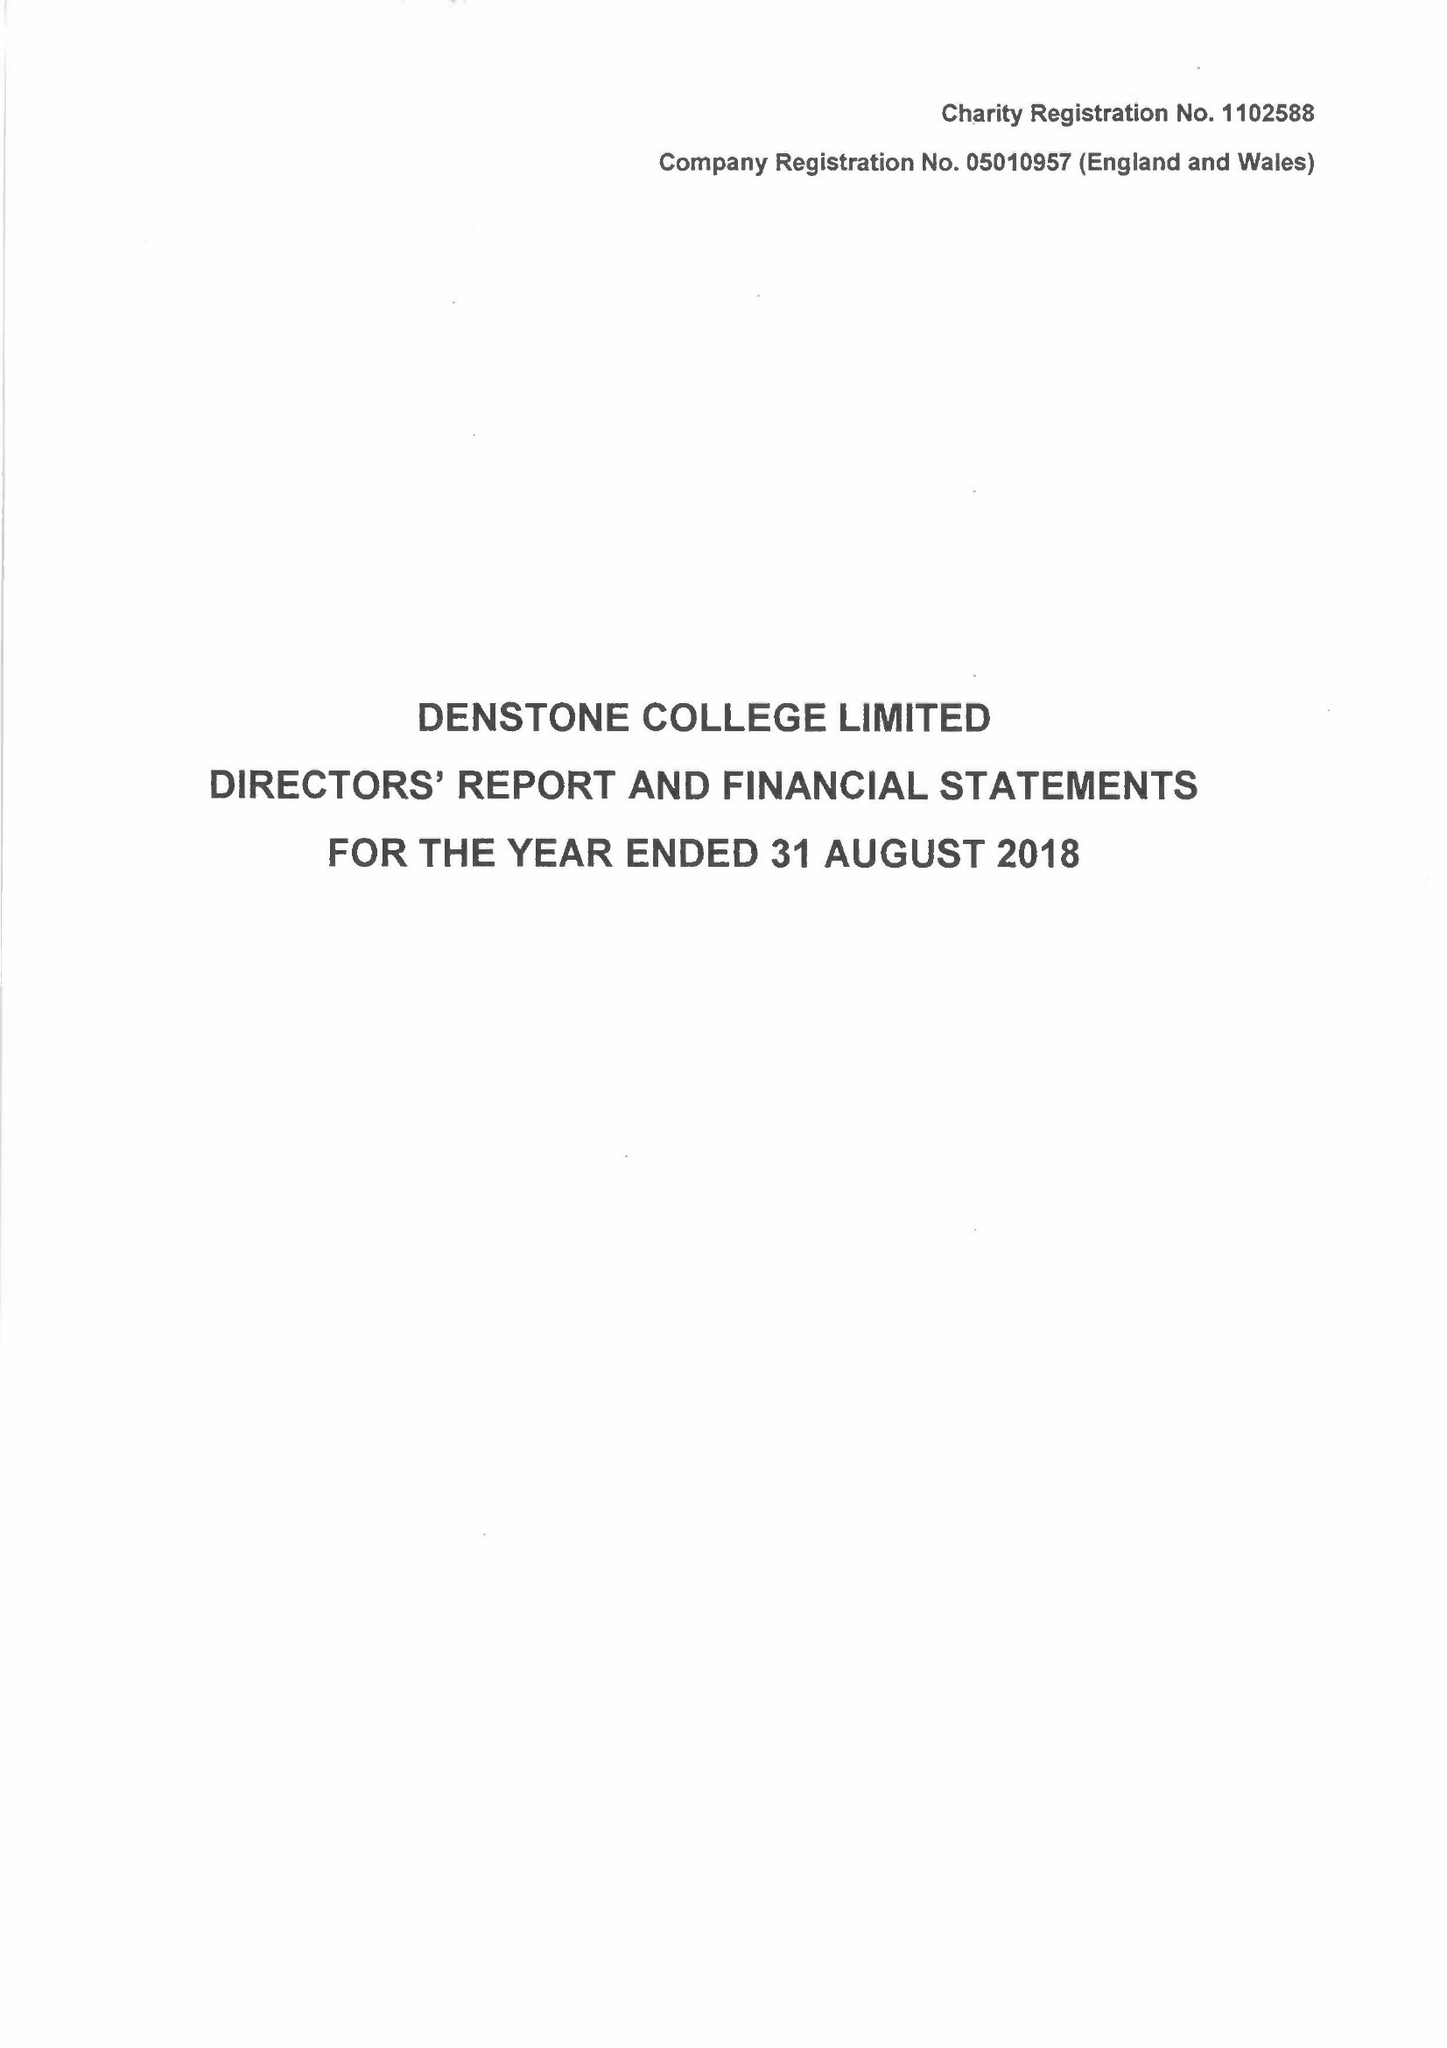What is the value for the spending_annually_in_british_pounds?
Answer the question using a single word or phrase. 10067302.00 